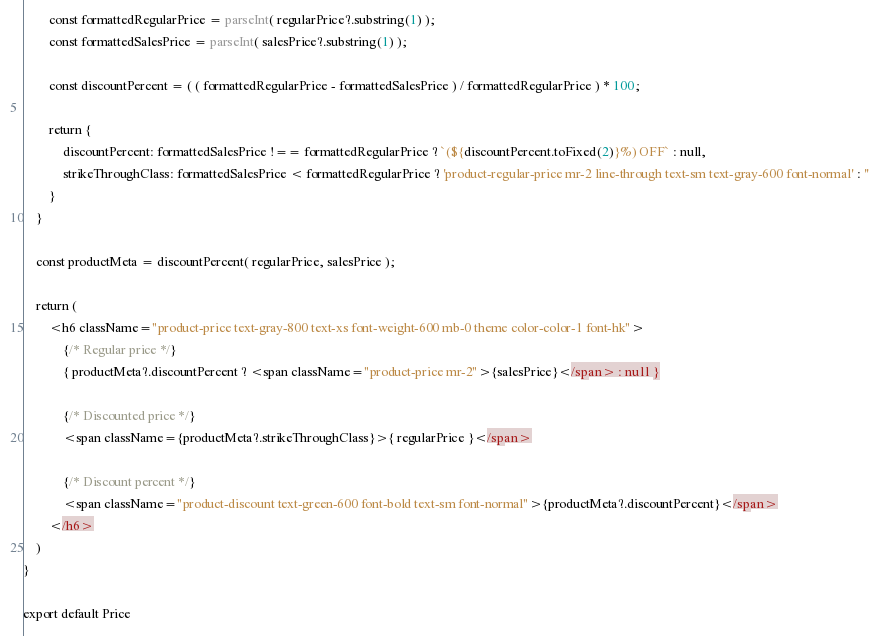<code> <loc_0><loc_0><loc_500><loc_500><_JavaScript_>        const formattedRegularPrice = parseInt( regularPrice?.substring(1) );
        const formattedSalesPrice = parseInt( salesPrice?.substring(1) );

        const discountPercent = ( ( formattedRegularPrice - formattedSalesPrice ) / formattedRegularPrice ) * 100;

        return {
            discountPercent: formattedSalesPrice !== formattedRegularPrice ? `(${discountPercent.toFixed(2)}%) OFF` : null,
            strikeThroughClass: formattedSalesPrice < formattedRegularPrice ? 'product-regular-price mr-2 line-through text-sm text-gray-600 font-normal' : ''
        }
    }

    const productMeta = discountPercent( regularPrice, salesPrice );

    return (
        <h6 className="product-price text-gray-800 text-xs font-weight-600 mb-0 theme color-color-1 font-hk">
            {/* Regular price */}
            { productMeta?.discountPercent ? <span className="product-price mr-2">{salesPrice}</span> : null }

            {/* Discounted price */}
            <span className={productMeta?.strikeThroughClass}>{ regularPrice }</span>

            {/* Discount percent */}
            <span className="product-discount text-green-600 font-bold text-sm font-normal">{productMeta?.discountPercent}</span>
        </h6>
    )
}

export default Price
</code> 